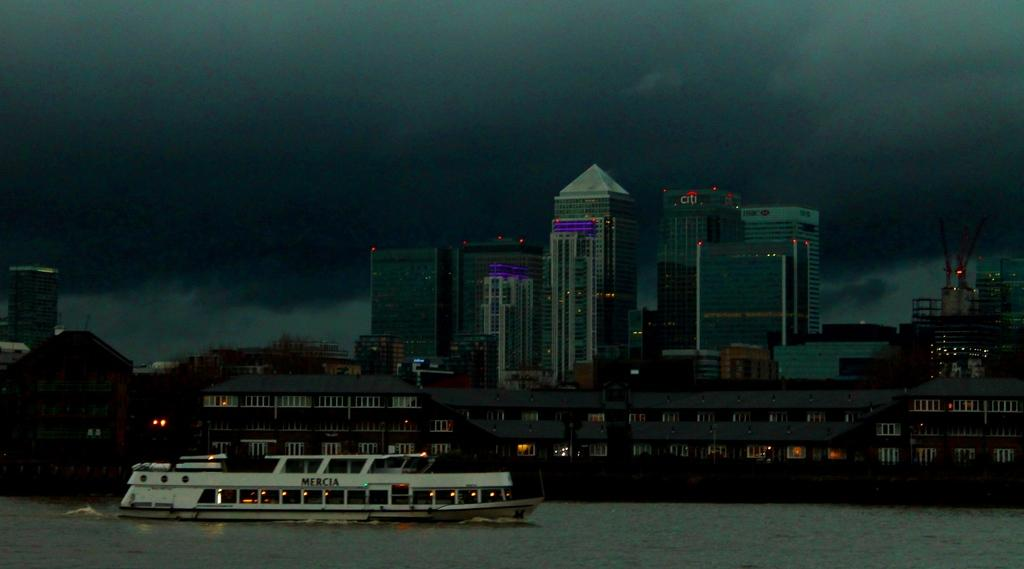<image>
Share a concise interpretation of the image provided. a boat on the water with the word 'mercia' on the side of it 